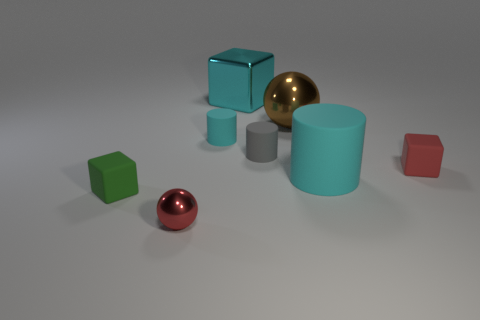Is there any other thing that is the same size as the gray rubber object?
Your answer should be very brief. Yes. There is a cube behind the red thing that is to the right of the big cyan cylinder; what is its material?
Make the answer very short. Metal. Is the big cyan metal thing the same shape as the red metallic object?
Your answer should be compact. No. What number of things are both behind the small red metal thing and left of the gray cylinder?
Make the answer very short. 3. Are there an equal number of tiny green blocks to the right of the green matte object and cyan metallic cubes that are to the right of the red matte object?
Provide a short and direct response. Yes. There is a thing that is on the left side of the small red metal thing; is its size the same as the red thing behind the red sphere?
Give a very brief answer. Yes. What material is the cyan thing that is both to the right of the tiny cyan matte thing and behind the gray object?
Make the answer very short. Metal. Are there fewer small green balls than gray matte cylinders?
Ensure brevity in your answer.  Yes. There is a matte cube right of the large cyan thing to the right of the big block; what size is it?
Offer a very short reply. Small. There is a big object that is in front of the big shiny object that is in front of the cyan object that is behind the large metal ball; what is its shape?
Offer a very short reply. Cylinder. 